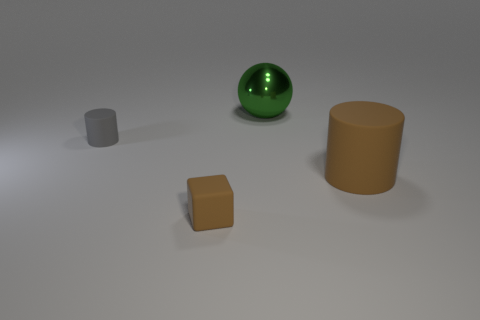Is there any other thing that has the same material as the large ball?
Provide a short and direct response. No. How big is the thing that is both to the left of the big ball and behind the cube?
Offer a very short reply. Small. What number of other small blocks have the same material as the small brown block?
Keep it short and to the point. 0. There is a large object that is made of the same material as the tiny brown block; what color is it?
Make the answer very short. Brown. Is the color of the small rubber object right of the small gray matte object the same as the big matte cylinder?
Make the answer very short. Yes. What is the cylinder that is in front of the tiny gray thing made of?
Your response must be concise. Rubber. Are there an equal number of brown rubber cubes that are left of the small matte cylinder and large green cylinders?
Give a very brief answer. Yes. How many tiny blocks are the same color as the ball?
Your response must be concise. 0. There is another matte thing that is the same shape as the gray rubber thing; what color is it?
Keep it short and to the point. Brown. Is the size of the green thing the same as the gray rubber thing?
Your answer should be very brief. No. 